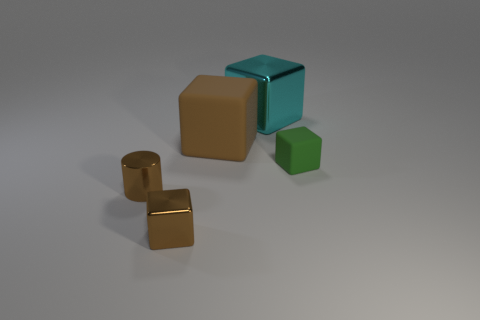Are there the same number of big brown matte blocks in front of the small shiny cylinder and large things?
Give a very brief answer. No. There is a small shiny cylinder; does it have the same color as the matte block behind the green matte object?
Provide a succinct answer. Yes. There is a object that is both behind the small brown cube and on the left side of the large brown matte cube; what color is it?
Provide a short and direct response. Brown. There is a small thing that is behind the small metal cylinder; how many small objects are in front of it?
Provide a short and direct response. 2. Is there a tiny green thing that has the same shape as the cyan object?
Offer a terse response. Yes. There is a matte thing behind the tiny matte thing; is its shape the same as the shiny thing that is behind the green rubber block?
Provide a succinct answer. Yes. How many objects are big green objects or small green cubes?
Your response must be concise. 1. There is a green rubber object that is the same shape as the big brown thing; what is its size?
Give a very brief answer. Small. Are there more big cyan blocks in front of the large cyan thing than blue cylinders?
Give a very brief answer. No. Do the big cyan thing and the tiny brown cube have the same material?
Provide a short and direct response. Yes. 